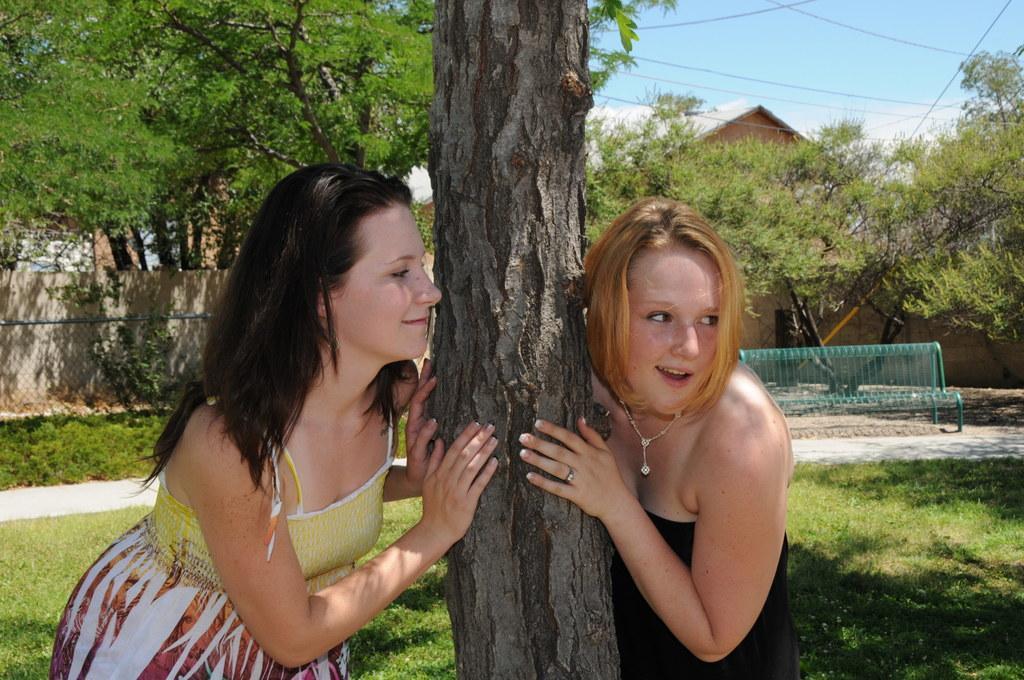Describe this image in one or two sentences. In this image we can see two women are standing. We can see a bark of a tree in the middle of the women. In the background, we can see a bench, grassy land, fence, buildings, wires and trees. At the top of the image, we can see the sky. 